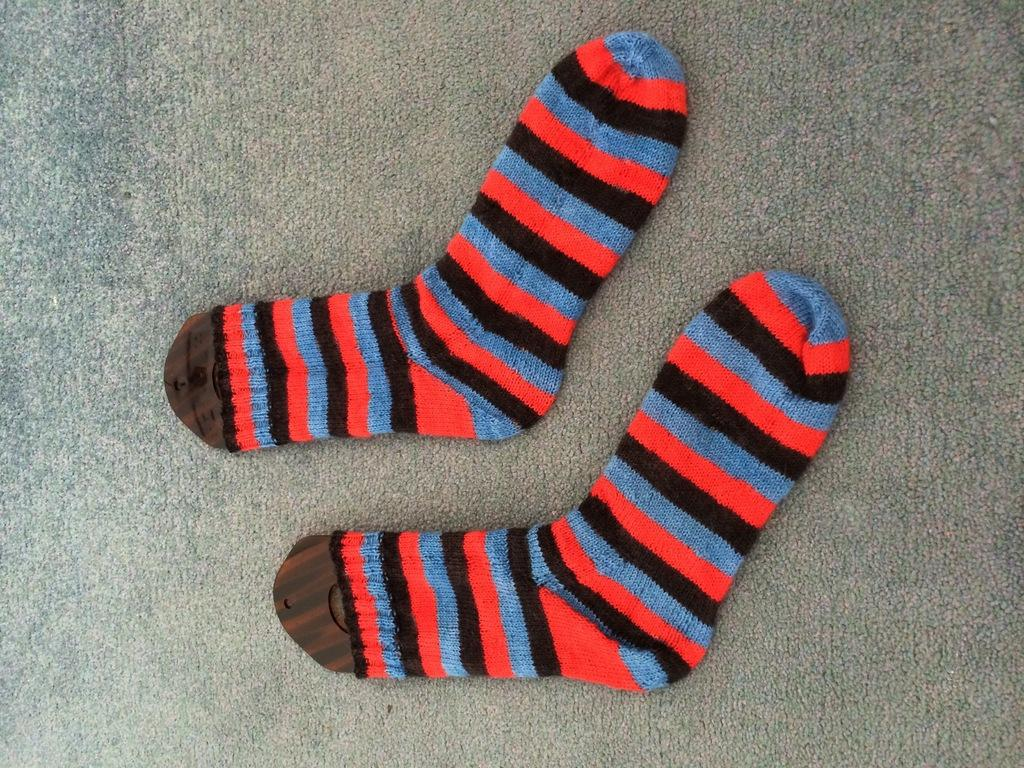What type of clothing item is visible in the image? There are socks in the image. Where are the socks located in the image? The socks are placed in the center of the image. On what surface are the socks placed? The socks are placed on an object that seems to be the floor. What type of sound does the bell make in the image? There is no bell present in the image. 